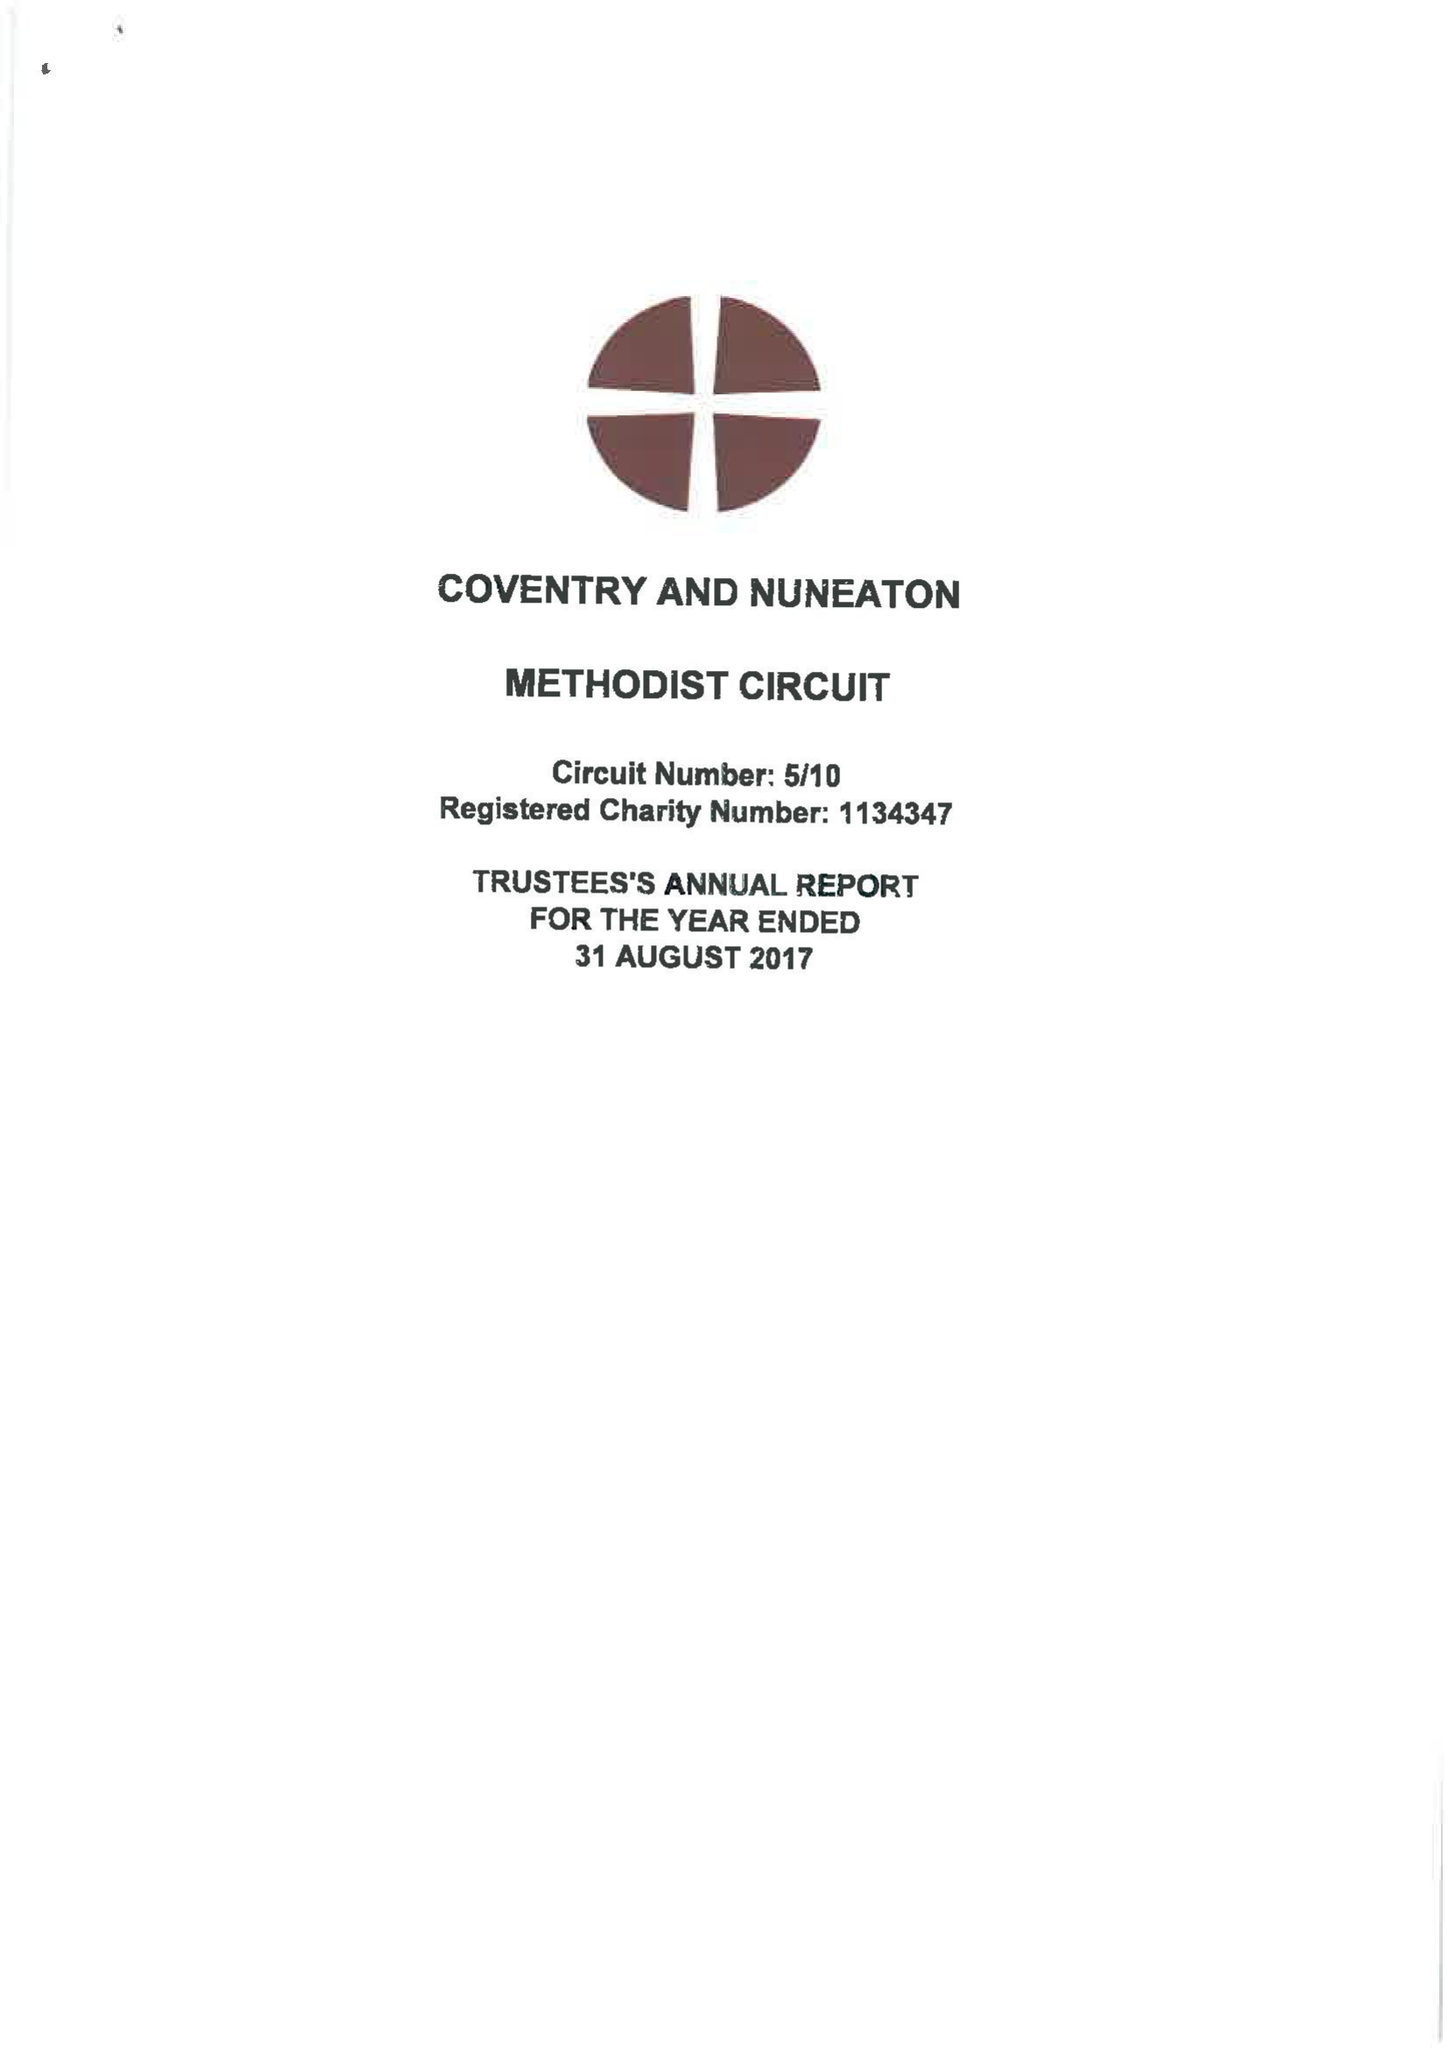What is the value for the address__postcode?
Answer the question using a single word or phrase. CV1 2HA 